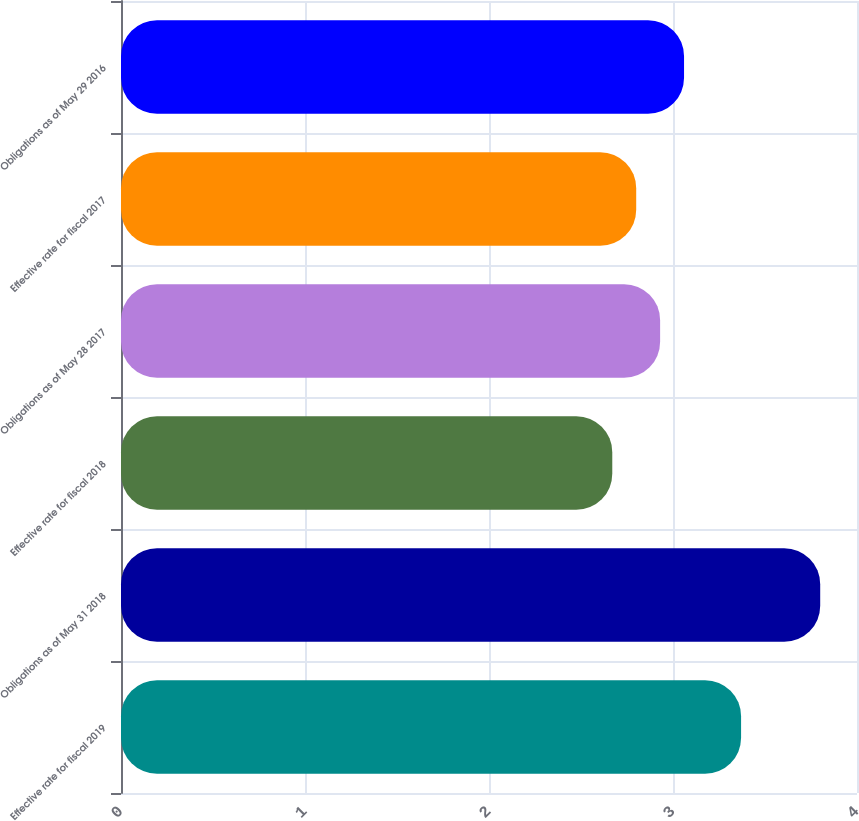<chart> <loc_0><loc_0><loc_500><loc_500><bar_chart><fcel>Effective rate for fiscal 2019<fcel>Obligations as of May 31 2018<fcel>Effective rate for fiscal 2018<fcel>Obligations as of May 28 2017<fcel>Effective rate for fiscal 2017<fcel>Obligations as of May 29 2016<nl><fcel>3.37<fcel>3.8<fcel>2.67<fcel>2.93<fcel>2.8<fcel>3.06<nl></chart> 